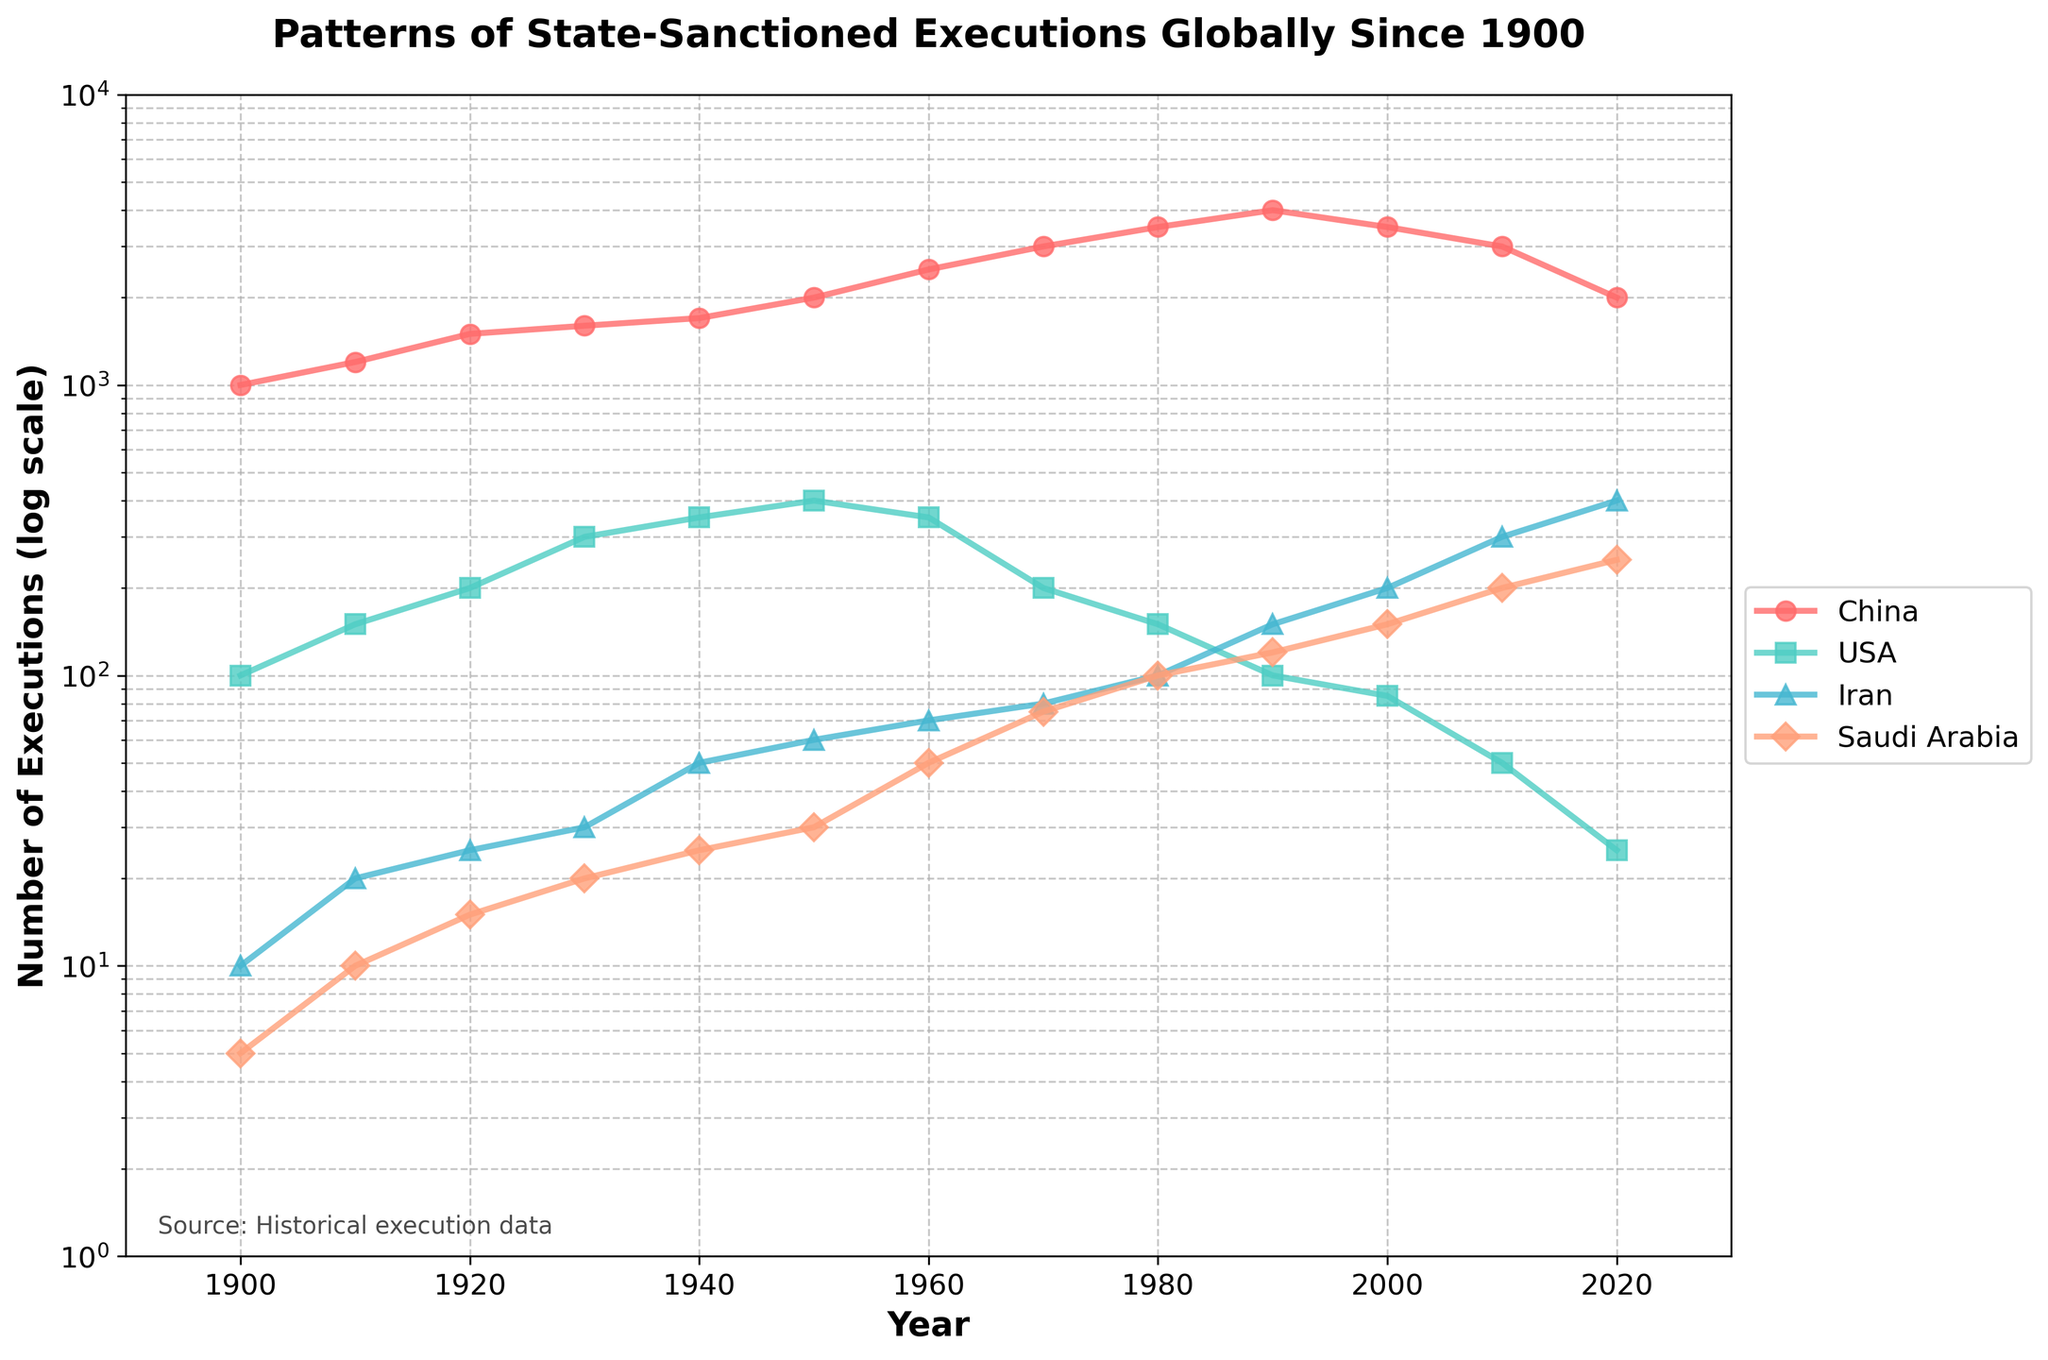What is the title of the figure? The title of the figure is displayed at the top. It reads "Patterns of State-Sanctioned Executions Globally Since 1900".
Answer: Patterns of State-Sanctioned Executions Globally Since 1900 Which country shows the highest number of executions throughout the years? By observing the line plot, we can see that China's line consistently represents the highest values on the y-axis from 1900 to 2020.
Answer: China What is the trend of executions in the USA from 1900 to 2020? The USA shows a trend where the number of executions increases until around 1940, then fluctuates slightly before declining steadily from around 1950 to 2020.
Answer: Increases until 1940, then declines steadily How many executions were recorded in Saudi Arabia in 2020? According to the plot, the value for Saudi Arabia in 2020 on the y-axis is approximately 250.
Answer: 250 Which country experienced the most significant increase in executions from 1900 to 2020? By comparing the starting and ending values for each country, Iran shows a significant increase from 10 executions in 1900 to 400 in 2020, marking the highest relative growth.
Answer: Iran Between which years did China see a decline in executions starting from its peak value? From the plot, China peaked around 1990 with 4000 executions and then declined afterward.
Answer: 1990 - 2020 Which country had the minimum number of executions in 1900? According to the plot, Saudi Arabia had the least with around 5 executions in 1900.
Answer: Saudi Arabia By how much did the number of executions in Iran increase from 1990 to 2020? Iran's execution numbers rose from 150 in 1990 to 400 in 2020. The difference is 400 - 150 = 250.
Answer: 250 Compare the number of executions in the USA in 1900 and 2020. The plot shows that in 1900, the USA had around 100 executions, and in 2020, it had approximately 25. Thus, it decreased by 75.
Answer: Decreased by 75 What are the x-axis and y-axis labels in the figure? The x-axis label reads "Year", and the y-axis label reads "Number of Executions (log scale)".
Answer: Year; Number of Executions (log scale) 